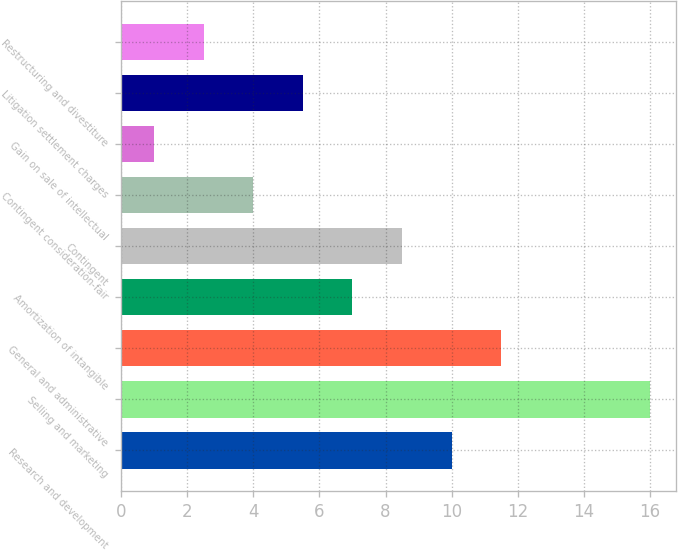Convert chart. <chart><loc_0><loc_0><loc_500><loc_500><bar_chart><fcel>Research and development<fcel>Selling and marketing<fcel>General and administrative<fcel>Amortization of intangible<fcel>Contingent<fcel>Contingent consideration-fair<fcel>Gain on sale of intellectual<fcel>Litigation settlement charges<fcel>Restructuring and divestiture<nl><fcel>10<fcel>16<fcel>11.5<fcel>7<fcel>8.5<fcel>4<fcel>1<fcel>5.5<fcel>2.5<nl></chart> 